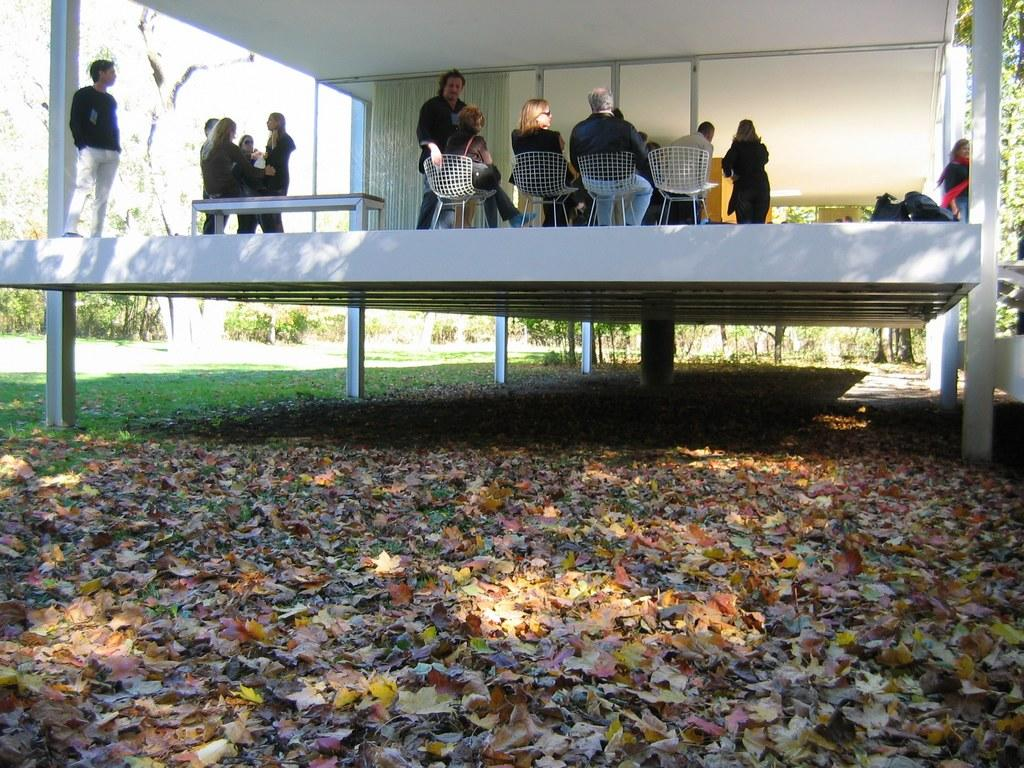What type of vegetation can be seen in the image? There are leaves in the image. What are the people in the image doing? Some people are sitting on chairs, while others are standing in the image. What piece of furniture is present in the image? There is a table in the image. What can be seen in the background of the image? There are trees in the background of the image. Where are the mice hiding in the image? There are no mice present in the image. What type of heart is visible in the image? There is no heart visible in the image. 